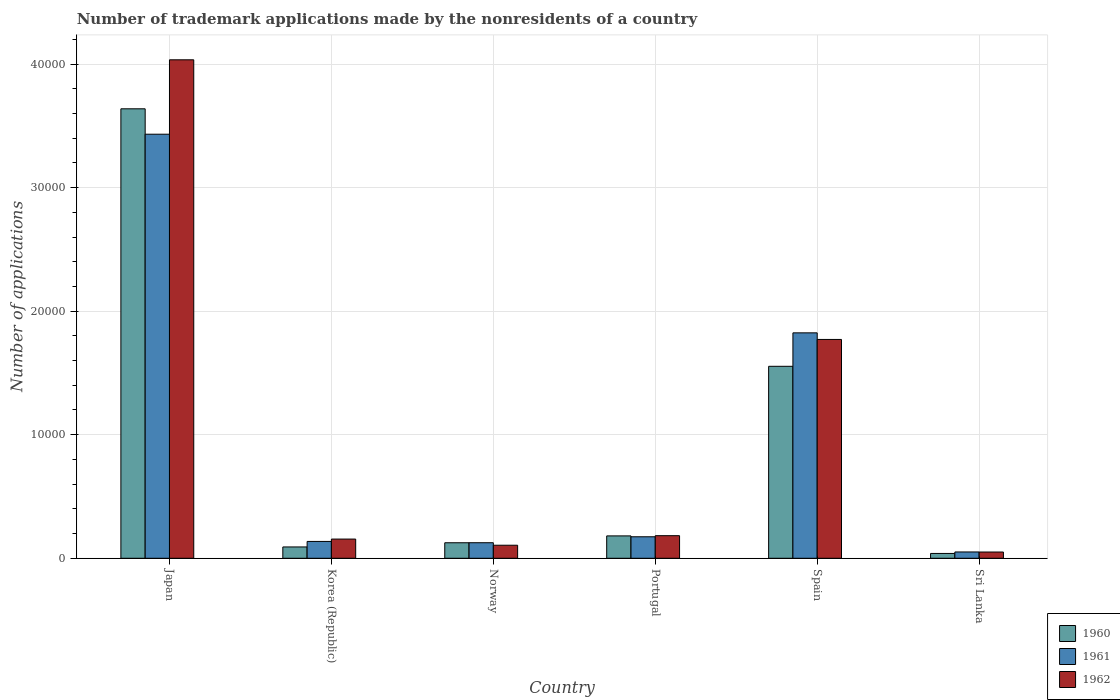How many different coloured bars are there?
Make the answer very short. 3. Are the number of bars on each tick of the X-axis equal?
Provide a succinct answer. Yes. How many bars are there on the 4th tick from the right?
Provide a short and direct response. 3. In how many cases, is the number of bars for a given country not equal to the number of legend labels?
Offer a terse response. 0. What is the number of trademark applications made by the nonresidents in 1962 in Norway?
Offer a very short reply. 1055. Across all countries, what is the maximum number of trademark applications made by the nonresidents in 1962?
Your answer should be very brief. 4.03e+04. Across all countries, what is the minimum number of trademark applications made by the nonresidents in 1960?
Your answer should be very brief. 391. In which country was the number of trademark applications made by the nonresidents in 1961 maximum?
Your answer should be compact. Japan. In which country was the number of trademark applications made by the nonresidents in 1961 minimum?
Offer a terse response. Sri Lanka. What is the total number of trademark applications made by the nonresidents in 1960 in the graph?
Make the answer very short. 5.63e+04. What is the difference between the number of trademark applications made by the nonresidents in 1962 in Portugal and that in Spain?
Your response must be concise. -1.59e+04. What is the difference between the number of trademark applications made by the nonresidents in 1960 in Sri Lanka and the number of trademark applications made by the nonresidents in 1962 in Japan?
Provide a succinct answer. -4.00e+04. What is the average number of trademark applications made by the nonresidents in 1960 per country?
Offer a terse response. 9381.17. What is the difference between the number of trademark applications made by the nonresidents of/in 1961 and number of trademark applications made by the nonresidents of/in 1962 in Norway?
Your answer should be very brief. 203. What is the ratio of the number of trademark applications made by the nonresidents in 1962 in Portugal to that in Spain?
Your response must be concise. 0.1. Is the number of trademark applications made by the nonresidents in 1962 in Japan less than that in Korea (Republic)?
Keep it short and to the point. No. Is the difference between the number of trademark applications made by the nonresidents in 1961 in Japan and Portugal greater than the difference between the number of trademark applications made by the nonresidents in 1962 in Japan and Portugal?
Your response must be concise. No. What is the difference between the highest and the second highest number of trademark applications made by the nonresidents in 1961?
Keep it short and to the point. 3.26e+04. What is the difference between the highest and the lowest number of trademark applications made by the nonresidents in 1960?
Make the answer very short. 3.60e+04. What does the 3rd bar from the right in Portugal represents?
Provide a succinct answer. 1960. Is it the case that in every country, the sum of the number of trademark applications made by the nonresidents in 1962 and number of trademark applications made by the nonresidents in 1960 is greater than the number of trademark applications made by the nonresidents in 1961?
Your answer should be compact. Yes. How many bars are there?
Your answer should be compact. 18. Are the values on the major ticks of Y-axis written in scientific E-notation?
Provide a short and direct response. No. Does the graph contain any zero values?
Provide a succinct answer. No. How are the legend labels stacked?
Provide a short and direct response. Vertical. What is the title of the graph?
Keep it short and to the point. Number of trademark applications made by the nonresidents of a country. Does "1966" appear as one of the legend labels in the graph?
Offer a terse response. No. What is the label or title of the X-axis?
Your answer should be very brief. Country. What is the label or title of the Y-axis?
Offer a terse response. Number of applications. What is the Number of applications of 1960 in Japan?
Offer a terse response. 3.64e+04. What is the Number of applications of 1961 in Japan?
Make the answer very short. 3.43e+04. What is the Number of applications of 1962 in Japan?
Provide a succinct answer. 4.03e+04. What is the Number of applications in 1960 in Korea (Republic)?
Make the answer very short. 916. What is the Number of applications of 1961 in Korea (Republic)?
Your response must be concise. 1363. What is the Number of applications in 1962 in Korea (Republic)?
Your response must be concise. 1554. What is the Number of applications of 1960 in Norway?
Offer a very short reply. 1255. What is the Number of applications of 1961 in Norway?
Offer a very short reply. 1258. What is the Number of applications of 1962 in Norway?
Keep it short and to the point. 1055. What is the Number of applications of 1960 in Portugal?
Offer a terse response. 1811. What is the Number of applications in 1961 in Portugal?
Offer a very short reply. 1740. What is the Number of applications in 1962 in Portugal?
Offer a very short reply. 1828. What is the Number of applications of 1960 in Spain?
Provide a succinct answer. 1.55e+04. What is the Number of applications of 1961 in Spain?
Keep it short and to the point. 1.82e+04. What is the Number of applications in 1962 in Spain?
Offer a very short reply. 1.77e+04. What is the Number of applications of 1960 in Sri Lanka?
Give a very brief answer. 391. What is the Number of applications in 1961 in Sri Lanka?
Your answer should be compact. 510. What is the Number of applications of 1962 in Sri Lanka?
Give a very brief answer. 506. Across all countries, what is the maximum Number of applications of 1960?
Keep it short and to the point. 3.64e+04. Across all countries, what is the maximum Number of applications of 1961?
Keep it short and to the point. 3.43e+04. Across all countries, what is the maximum Number of applications of 1962?
Give a very brief answer. 4.03e+04. Across all countries, what is the minimum Number of applications of 1960?
Ensure brevity in your answer.  391. Across all countries, what is the minimum Number of applications of 1961?
Keep it short and to the point. 510. Across all countries, what is the minimum Number of applications of 1962?
Your response must be concise. 506. What is the total Number of applications of 1960 in the graph?
Give a very brief answer. 5.63e+04. What is the total Number of applications in 1961 in the graph?
Provide a short and direct response. 5.74e+04. What is the total Number of applications in 1962 in the graph?
Provide a short and direct response. 6.30e+04. What is the difference between the Number of applications in 1960 in Japan and that in Korea (Republic)?
Your answer should be compact. 3.55e+04. What is the difference between the Number of applications in 1961 in Japan and that in Korea (Republic)?
Your answer should be very brief. 3.30e+04. What is the difference between the Number of applications of 1962 in Japan and that in Korea (Republic)?
Keep it short and to the point. 3.88e+04. What is the difference between the Number of applications of 1960 in Japan and that in Norway?
Your answer should be compact. 3.51e+04. What is the difference between the Number of applications of 1961 in Japan and that in Norway?
Your response must be concise. 3.31e+04. What is the difference between the Number of applications of 1962 in Japan and that in Norway?
Your answer should be compact. 3.93e+04. What is the difference between the Number of applications in 1960 in Japan and that in Portugal?
Offer a very short reply. 3.46e+04. What is the difference between the Number of applications of 1961 in Japan and that in Portugal?
Offer a terse response. 3.26e+04. What is the difference between the Number of applications in 1962 in Japan and that in Portugal?
Offer a terse response. 3.85e+04. What is the difference between the Number of applications in 1960 in Japan and that in Spain?
Provide a succinct answer. 2.08e+04. What is the difference between the Number of applications of 1961 in Japan and that in Spain?
Offer a very short reply. 1.61e+04. What is the difference between the Number of applications of 1962 in Japan and that in Spain?
Make the answer very short. 2.26e+04. What is the difference between the Number of applications in 1960 in Japan and that in Sri Lanka?
Your answer should be very brief. 3.60e+04. What is the difference between the Number of applications of 1961 in Japan and that in Sri Lanka?
Provide a short and direct response. 3.38e+04. What is the difference between the Number of applications in 1962 in Japan and that in Sri Lanka?
Give a very brief answer. 3.98e+04. What is the difference between the Number of applications in 1960 in Korea (Republic) and that in Norway?
Make the answer very short. -339. What is the difference between the Number of applications in 1961 in Korea (Republic) and that in Norway?
Keep it short and to the point. 105. What is the difference between the Number of applications in 1962 in Korea (Republic) and that in Norway?
Offer a terse response. 499. What is the difference between the Number of applications of 1960 in Korea (Republic) and that in Portugal?
Ensure brevity in your answer.  -895. What is the difference between the Number of applications in 1961 in Korea (Republic) and that in Portugal?
Keep it short and to the point. -377. What is the difference between the Number of applications in 1962 in Korea (Republic) and that in Portugal?
Keep it short and to the point. -274. What is the difference between the Number of applications in 1960 in Korea (Republic) and that in Spain?
Offer a terse response. -1.46e+04. What is the difference between the Number of applications in 1961 in Korea (Republic) and that in Spain?
Your response must be concise. -1.69e+04. What is the difference between the Number of applications in 1962 in Korea (Republic) and that in Spain?
Provide a short and direct response. -1.62e+04. What is the difference between the Number of applications of 1960 in Korea (Republic) and that in Sri Lanka?
Provide a succinct answer. 525. What is the difference between the Number of applications of 1961 in Korea (Republic) and that in Sri Lanka?
Provide a short and direct response. 853. What is the difference between the Number of applications in 1962 in Korea (Republic) and that in Sri Lanka?
Your answer should be compact. 1048. What is the difference between the Number of applications in 1960 in Norway and that in Portugal?
Your answer should be compact. -556. What is the difference between the Number of applications of 1961 in Norway and that in Portugal?
Offer a very short reply. -482. What is the difference between the Number of applications of 1962 in Norway and that in Portugal?
Provide a succinct answer. -773. What is the difference between the Number of applications in 1960 in Norway and that in Spain?
Your response must be concise. -1.43e+04. What is the difference between the Number of applications of 1961 in Norway and that in Spain?
Your answer should be compact. -1.70e+04. What is the difference between the Number of applications in 1962 in Norway and that in Spain?
Your answer should be very brief. -1.67e+04. What is the difference between the Number of applications of 1960 in Norway and that in Sri Lanka?
Your response must be concise. 864. What is the difference between the Number of applications in 1961 in Norway and that in Sri Lanka?
Keep it short and to the point. 748. What is the difference between the Number of applications in 1962 in Norway and that in Sri Lanka?
Your answer should be compact. 549. What is the difference between the Number of applications in 1960 in Portugal and that in Spain?
Your answer should be compact. -1.37e+04. What is the difference between the Number of applications of 1961 in Portugal and that in Spain?
Keep it short and to the point. -1.65e+04. What is the difference between the Number of applications in 1962 in Portugal and that in Spain?
Offer a very short reply. -1.59e+04. What is the difference between the Number of applications in 1960 in Portugal and that in Sri Lanka?
Offer a terse response. 1420. What is the difference between the Number of applications in 1961 in Portugal and that in Sri Lanka?
Make the answer very short. 1230. What is the difference between the Number of applications in 1962 in Portugal and that in Sri Lanka?
Give a very brief answer. 1322. What is the difference between the Number of applications of 1960 in Spain and that in Sri Lanka?
Your answer should be very brief. 1.51e+04. What is the difference between the Number of applications of 1961 in Spain and that in Sri Lanka?
Ensure brevity in your answer.  1.77e+04. What is the difference between the Number of applications of 1962 in Spain and that in Sri Lanka?
Offer a very short reply. 1.72e+04. What is the difference between the Number of applications in 1960 in Japan and the Number of applications in 1961 in Korea (Republic)?
Ensure brevity in your answer.  3.50e+04. What is the difference between the Number of applications of 1960 in Japan and the Number of applications of 1962 in Korea (Republic)?
Offer a very short reply. 3.48e+04. What is the difference between the Number of applications of 1961 in Japan and the Number of applications of 1962 in Korea (Republic)?
Keep it short and to the point. 3.28e+04. What is the difference between the Number of applications of 1960 in Japan and the Number of applications of 1961 in Norway?
Make the answer very short. 3.51e+04. What is the difference between the Number of applications in 1960 in Japan and the Number of applications in 1962 in Norway?
Your answer should be compact. 3.53e+04. What is the difference between the Number of applications in 1961 in Japan and the Number of applications in 1962 in Norway?
Provide a short and direct response. 3.33e+04. What is the difference between the Number of applications of 1960 in Japan and the Number of applications of 1961 in Portugal?
Provide a short and direct response. 3.46e+04. What is the difference between the Number of applications of 1960 in Japan and the Number of applications of 1962 in Portugal?
Your response must be concise. 3.45e+04. What is the difference between the Number of applications in 1961 in Japan and the Number of applications in 1962 in Portugal?
Your response must be concise. 3.25e+04. What is the difference between the Number of applications in 1960 in Japan and the Number of applications in 1961 in Spain?
Your answer should be compact. 1.81e+04. What is the difference between the Number of applications of 1960 in Japan and the Number of applications of 1962 in Spain?
Offer a terse response. 1.87e+04. What is the difference between the Number of applications in 1961 in Japan and the Number of applications in 1962 in Spain?
Keep it short and to the point. 1.66e+04. What is the difference between the Number of applications in 1960 in Japan and the Number of applications in 1961 in Sri Lanka?
Provide a succinct answer. 3.59e+04. What is the difference between the Number of applications in 1960 in Japan and the Number of applications in 1962 in Sri Lanka?
Keep it short and to the point. 3.59e+04. What is the difference between the Number of applications of 1961 in Japan and the Number of applications of 1962 in Sri Lanka?
Your response must be concise. 3.38e+04. What is the difference between the Number of applications in 1960 in Korea (Republic) and the Number of applications in 1961 in Norway?
Make the answer very short. -342. What is the difference between the Number of applications in 1960 in Korea (Republic) and the Number of applications in 1962 in Norway?
Your response must be concise. -139. What is the difference between the Number of applications in 1961 in Korea (Republic) and the Number of applications in 1962 in Norway?
Provide a succinct answer. 308. What is the difference between the Number of applications in 1960 in Korea (Republic) and the Number of applications in 1961 in Portugal?
Your answer should be very brief. -824. What is the difference between the Number of applications in 1960 in Korea (Republic) and the Number of applications in 1962 in Portugal?
Keep it short and to the point. -912. What is the difference between the Number of applications of 1961 in Korea (Republic) and the Number of applications of 1962 in Portugal?
Your answer should be compact. -465. What is the difference between the Number of applications of 1960 in Korea (Republic) and the Number of applications of 1961 in Spain?
Provide a succinct answer. -1.73e+04. What is the difference between the Number of applications of 1960 in Korea (Republic) and the Number of applications of 1962 in Spain?
Provide a short and direct response. -1.68e+04. What is the difference between the Number of applications in 1961 in Korea (Republic) and the Number of applications in 1962 in Spain?
Your response must be concise. -1.63e+04. What is the difference between the Number of applications in 1960 in Korea (Republic) and the Number of applications in 1961 in Sri Lanka?
Your answer should be compact. 406. What is the difference between the Number of applications of 1960 in Korea (Republic) and the Number of applications of 1962 in Sri Lanka?
Offer a terse response. 410. What is the difference between the Number of applications of 1961 in Korea (Republic) and the Number of applications of 1962 in Sri Lanka?
Offer a very short reply. 857. What is the difference between the Number of applications in 1960 in Norway and the Number of applications in 1961 in Portugal?
Make the answer very short. -485. What is the difference between the Number of applications of 1960 in Norway and the Number of applications of 1962 in Portugal?
Keep it short and to the point. -573. What is the difference between the Number of applications in 1961 in Norway and the Number of applications in 1962 in Portugal?
Offer a very short reply. -570. What is the difference between the Number of applications of 1960 in Norway and the Number of applications of 1961 in Spain?
Your answer should be compact. -1.70e+04. What is the difference between the Number of applications in 1960 in Norway and the Number of applications in 1962 in Spain?
Make the answer very short. -1.65e+04. What is the difference between the Number of applications in 1961 in Norway and the Number of applications in 1962 in Spain?
Provide a short and direct response. -1.65e+04. What is the difference between the Number of applications of 1960 in Norway and the Number of applications of 1961 in Sri Lanka?
Provide a succinct answer. 745. What is the difference between the Number of applications in 1960 in Norway and the Number of applications in 1962 in Sri Lanka?
Offer a very short reply. 749. What is the difference between the Number of applications in 1961 in Norway and the Number of applications in 1962 in Sri Lanka?
Your response must be concise. 752. What is the difference between the Number of applications of 1960 in Portugal and the Number of applications of 1961 in Spain?
Your answer should be compact. -1.64e+04. What is the difference between the Number of applications in 1960 in Portugal and the Number of applications in 1962 in Spain?
Your response must be concise. -1.59e+04. What is the difference between the Number of applications in 1961 in Portugal and the Number of applications in 1962 in Spain?
Your answer should be compact. -1.60e+04. What is the difference between the Number of applications of 1960 in Portugal and the Number of applications of 1961 in Sri Lanka?
Make the answer very short. 1301. What is the difference between the Number of applications of 1960 in Portugal and the Number of applications of 1962 in Sri Lanka?
Your response must be concise. 1305. What is the difference between the Number of applications of 1961 in Portugal and the Number of applications of 1962 in Sri Lanka?
Your answer should be very brief. 1234. What is the difference between the Number of applications in 1960 in Spain and the Number of applications in 1961 in Sri Lanka?
Provide a succinct answer. 1.50e+04. What is the difference between the Number of applications of 1960 in Spain and the Number of applications of 1962 in Sri Lanka?
Provide a succinct answer. 1.50e+04. What is the difference between the Number of applications of 1961 in Spain and the Number of applications of 1962 in Sri Lanka?
Your response must be concise. 1.77e+04. What is the average Number of applications of 1960 per country?
Provide a succinct answer. 9381.17. What is the average Number of applications in 1961 per country?
Provide a short and direct response. 9572.5. What is the average Number of applications of 1962 per country?
Provide a succinct answer. 1.05e+04. What is the difference between the Number of applications of 1960 and Number of applications of 1961 in Japan?
Offer a terse response. 2057. What is the difference between the Number of applications of 1960 and Number of applications of 1962 in Japan?
Make the answer very short. -3966. What is the difference between the Number of applications in 1961 and Number of applications in 1962 in Japan?
Provide a short and direct response. -6023. What is the difference between the Number of applications in 1960 and Number of applications in 1961 in Korea (Republic)?
Keep it short and to the point. -447. What is the difference between the Number of applications of 1960 and Number of applications of 1962 in Korea (Republic)?
Give a very brief answer. -638. What is the difference between the Number of applications of 1961 and Number of applications of 1962 in Korea (Republic)?
Make the answer very short. -191. What is the difference between the Number of applications of 1960 and Number of applications of 1961 in Norway?
Offer a terse response. -3. What is the difference between the Number of applications of 1961 and Number of applications of 1962 in Norway?
Keep it short and to the point. 203. What is the difference between the Number of applications in 1960 and Number of applications in 1962 in Portugal?
Give a very brief answer. -17. What is the difference between the Number of applications in 1961 and Number of applications in 1962 in Portugal?
Provide a short and direct response. -88. What is the difference between the Number of applications in 1960 and Number of applications in 1961 in Spain?
Your answer should be compact. -2707. What is the difference between the Number of applications of 1960 and Number of applications of 1962 in Spain?
Give a very brief answer. -2173. What is the difference between the Number of applications of 1961 and Number of applications of 1962 in Spain?
Provide a short and direct response. 534. What is the difference between the Number of applications of 1960 and Number of applications of 1961 in Sri Lanka?
Make the answer very short. -119. What is the difference between the Number of applications of 1960 and Number of applications of 1962 in Sri Lanka?
Provide a succinct answer. -115. What is the ratio of the Number of applications in 1960 in Japan to that in Korea (Republic)?
Provide a succinct answer. 39.71. What is the ratio of the Number of applications in 1961 in Japan to that in Korea (Republic)?
Your answer should be compact. 25.18. What is the ratio of the Number of applications in 1962 in Japan to that in Korea (Republic)?
Make the answer very short. 25.96. What is the ratio of the Number of applications in 1960 in Japan to that in Norway?
Keep it short and to the point. 28.99. What is the ratio of the Number of applications in 1961 in Japan to that in Norway?
Offer a terse response. 27.28. What is the ratio of the Number of applications of 1962 in Japan to that in Norway?
Make the answer very short. 38.24. What is the ratio of the Number of applications of 1960 in Japan to that in Portugal?
Ensure brevity in your answer.  20.09. What is the ratio of the Number of applications in 1961 in Japan to that in Portugal?
Provide a succinct answer. 19.72. What is the ratio of the Number of applications in 1962 in Japan to that in Portugal?
Your response must be concise. 22.07. What is the ratio of the Number of applications of 1960 in Japan to that in Spain?
Give a very brief answer. 2.34. What is the ratio of the Number of applications in 1961 in Japan to that in Spain?
Your answer should be compact. 1.88. What is the ratio of the Number of applications of 1962 in Japan to that in Spain?
Ensure brevity in your answer.  2.28. What is the ratio of the Number of applications of 1960 in Japan to that in Sri Lanka?
Offer a terse response. 93.04. What is the ratio of the Number of applications in 1961 in Japan to that in Sri Lanka?
Provide a short and direct response. 67.29. What is the ratio of the Number of applications in 1962 in Japan to that in Sri Lanka?
Offer a terse response. 79.73. What is the ratio of the Number of applications of 1960 in Korea (Republic) to that in Norway?
Ensure brevity in your answer.  0.73. What is the ratio of the Number of applications in 1961 in Korea (Republic) to that in Norway?
Ensure brevity in your answer.  1.08. What is the ratio of the Number of applications of 1962 in Korea (Republic) to that in Norway?
Give a very brief answer. 1.47. What is the ratio of the Number of applications in 1960 in Korea (Republic) to that in Portugal?
Provide a short and direct response. 0.51. What is the ratio of the Number of applications of 1961 in Korea (Republic) to that in Portugal?
Offer a very short reply. 0.78. What is the ratio of the Number of applications of 1962 in Korea (Republic) to that in Portugal?
Keep it short and to the point. 0.85. What is the ratio of the Number of applications in 1960 in Korea (Republic) to that in Spain?
Provide a short and direct response. 0.06. What is the ratio of the Number of applications in 1961 in Korea (Republic) to that in Spain?
Offer a terse response. 0.07. What is the ratio of the Number of applications of 1962 in Korea (Republic) to that in Spain?
Offer a very short reply. 0.09. What is the ratio of the Number of applications in 1960 in Korea (Republic) to that in Sri Lanka?
Keep it short and to the point. 2.34. What is the ratio of the Number of applications of 1961 in Korea (Republic) to that in Sri Lanka?
Your response must be concise. 2.67. What is the ratio of the Number of applications of 1962 in Korea (Republic) to that in Sri Lanka?
Your answer should be very brief. 3.07. What is the ratio of the Number of applications of 1960 in Norway to that in Portugal?
Offer a terse response. 0.69. What is the ratio of the Number of applications of 1961 in Norway to that in Portugal?
Provide a short and direct response. 0.72. What is the ratio of the Number of applications in 1962 in Norway to that in Portugal?
Offer a very short reply. 0.58. What is the ratio of the Number of applications of 1960 in Norway to that in Spain?
Your answer should be very brief. 0.08. What is the ratio of the Number of applications of 1961 in Norway to that in Spain?
Provide a succinct answer. 0.07. What is the ratio of the Number of applications of 1962 in Norway to that in Spain?
Make the answer very short. 0.06. What is the ratio of the Number of applications of 1960 in Norway to that in Sri Lanka?
Give a very brief answer. 3.21. What is the ratio of the Number of applications of 1961 in Norway to that in Sri Lanka?
Your answer should be very brief. 2.47. What is the ratio of the Number of applications of 1962 in Norway to that in Sri Lanka?
Your answer should be very brief. 2.08. What is the ratio of the Number of applications in 1960 in Portugal to that in Spain?
Keep it short and to the point. 0.12. What is the ratio of the Number of applications of 1961 in Portugal to that in Spain?
Provide a succinct answer. 0.1. What is the ratio of the Number of applications of 1962 in Portugal to that in Spain?
Provide a succinct answer. 0.1. What is the ratio of the Number of applications of 1960 in Portugal to that in Sri Lanka?
Your answer should be very brief. 4.63. What is the ratio of the Number of applications of 1961 in Portugal to that in Sri Lanka?
Offer a very short reply. 3.41. What is the ratio of the Number of applications of 1962 in Portugal to that in Sri Lanka?
Offer a very short reply. 3.61. What is the ratio of the Number of applications in 1960 in Spain to that in Sri Lanka?
Offer a very short reply. 39.74. What is the ratio of the Number of applications of 1961 in Spain to that in Sri Lanka?
Ensure brevity in your answer.  35.77. What is the ratio of the Number of applications in 1962 in Spain to that in Sri Lanka?
Provide a succinct answer. 35. What is the difference between the highest and the second highest Number of applications of 1960?
Offer a very short reply. 2.08e+04. What is the difference between the highest and the second highest Number of applications in 1961?
Keep it short and to the point. 1.61e+04. What is the difference between the highest and the second highest Number of applications in 1962?
Your response must be concise. 2.26e+04. What is the difference between the highest and the lowest Number of applications in 1960?
Make the answer very short. 3.60e+04. What is the difference between the highest and the lowest Number of applications of 1961?
Provide a succinct answer. 3.38e+04. What is the difference between the highest and the lowest Number of applications in 1962?
Make the answer very short. 3.98e+04. 